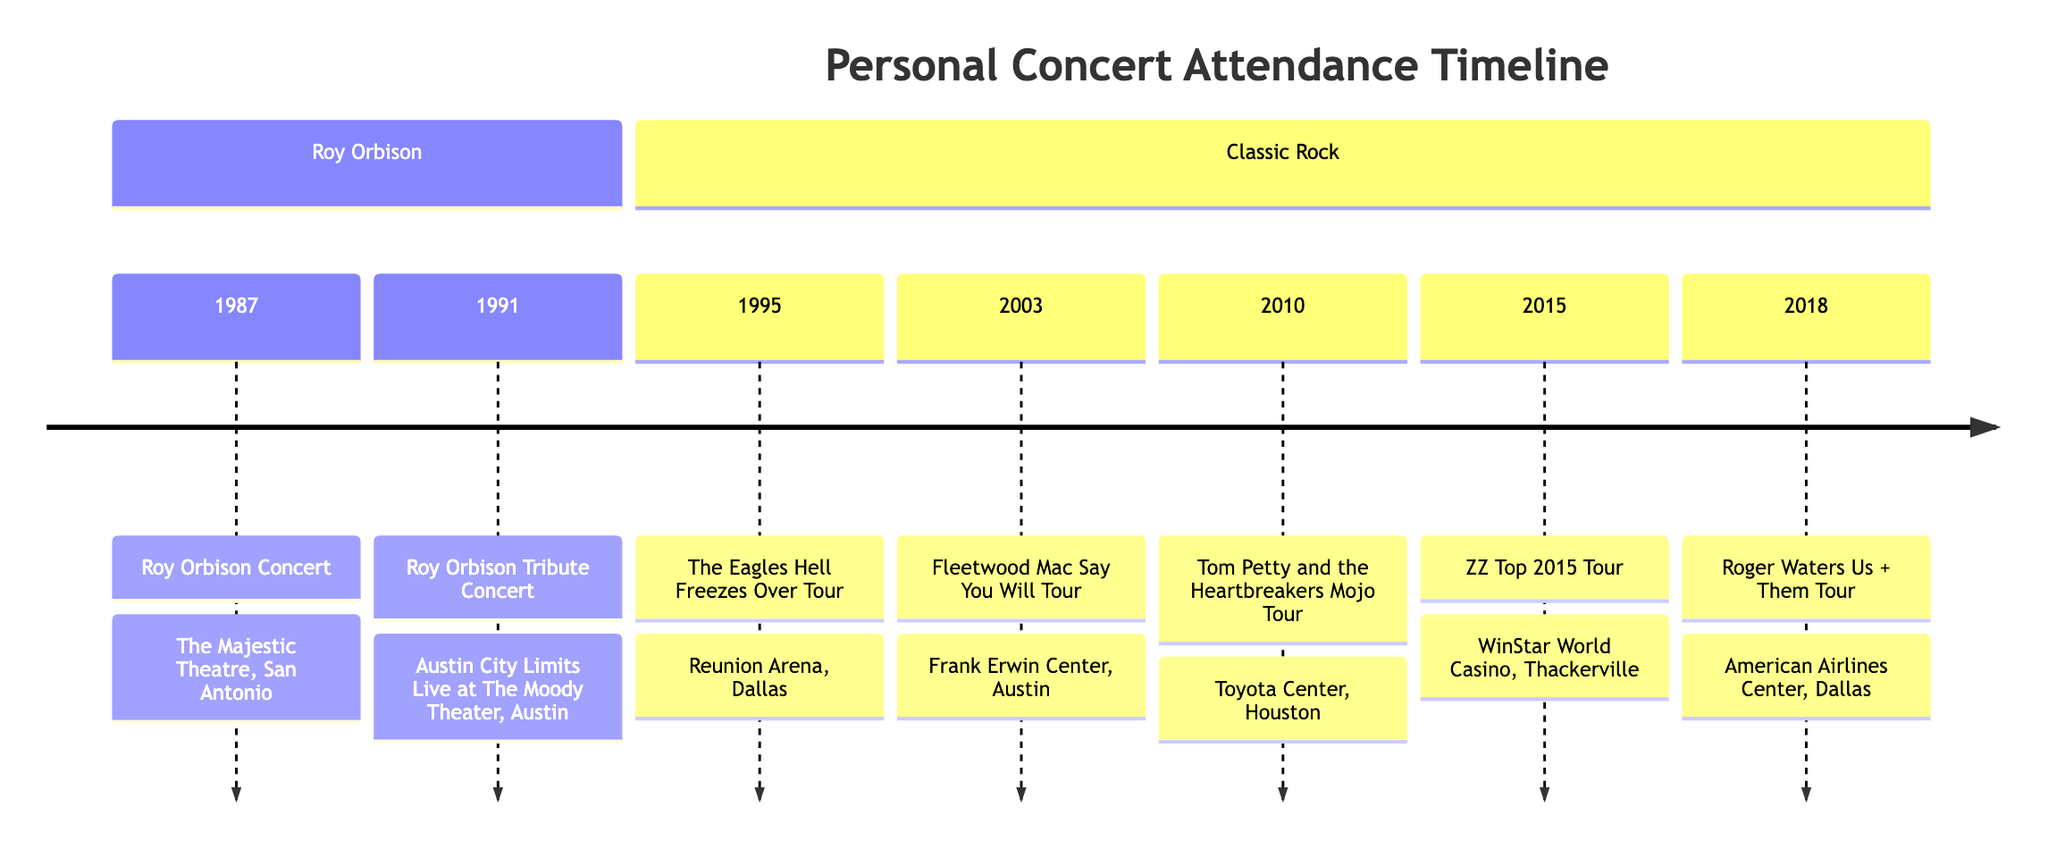What event took place on April 17, 1987? The diagram shows that on April 17, 1987, a Roy Orbison Concert occurred at The Majestic Theatre in San Antonio.
Answer: Roy Orbison Concert How many concerts were attended that featured Roy Orbison? The diagram highlights two events that feature Roy Orbison: one concert in 1987 and one tribute concert in 1991, making it a total of two concerts.
Answer: 2 Which venue hosted the most concerts in this timeline? By examining the timeline, we can see various venues listed; however, the events do not repeat in any single venue. Thus, no venue has hosted multiple concerts in this timeline.
Answer: None What was the date of the ZZ Top concert? According to the timeline, the ZZ Top concert took place on September 12, 2015.
Answer: September 12, 2015 Which event had a notable performance of 'Comfortably Numb'? The diagram indicates that the Roger Waters Us + Them Tour had the highlight of 'Comfortably Numb' during the performance, as detailed in the notes for that event.
Answer: Roger Waters Us + Them Tour How many classic rock concerts are listed in the timeline? The timeline includes five events classified under classic rock, which are clearly delineated from Roy Orbison's events.
Answer: 5 Who performed a tribute concert in Austin in 1991? The timeline shows that the tribute concert in 1991 included various artists such as Bruce Springsteen and k.d. lang, but highlights it was a Roy Orbison Tribute Concert.
Answer: Bruce Springsteen and k.d. lang What city hosted the Fleetwood Mac concert? The Fleetwood Mac Say You Will Tour concert was held in Austin, as noted in the timeline.
Answer: Austin What was the highlight of the Eagles concert? The notes on the Eagles Hell Freezes Over Tour in this timeline mention that the hotel California encore left a lasting impression, which can be deemed as the highlight of that event.
Answer: Hotel California encore 